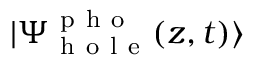<formula> <loc_0><loc_0><loc_500><loc_500>| \Psi _ { h o l e } ^ { p h o } ( z , t ) \rangle</formula> 